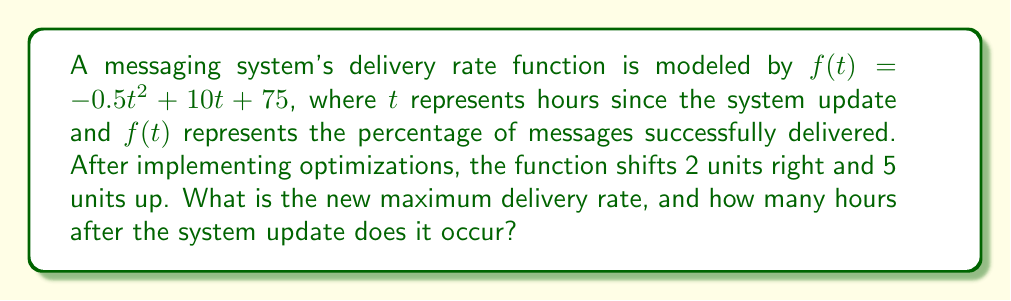Teach me how to tackle this problem. Let's approach this step-by-step:

1) The original function is $f(t) = -0.5t^2 + 10t + 75$

2) After the shifts, the new function $g(t)$ is:
   $g(t) = -0.5(t-2)^2 + 10(t-2) + 75 + 5$

3) Expand $g(t)$:
   $g(t) = -0.5(t^2 - 4t + 4) + 10t - 20 + 80$
   $g(t) = -0.5t^2 + 2t - 2 + 10t - 20 + 80$
   $g(t) = -0.5t^2 + 12t + 58$

4) To find the maximum, we need to find the vertex of this parabola. For a quadratic function $at^2 + bt + c$, the t-coordinate of the vertex is given by $-b/(2a)$

5) Here, $a = -0.5$ and $b = 12$
   $t = -12 / (2(-0.5)) = 12$

6) The maximum occurs 12 hours after the system update

7) To find the maximum delivery rate, we substitute $t = 12$ into $g(t)$:
   $g(12) = -0.5(12)^2 + 12(12) + 58$
   $g(12) = -72 + 144 + 58 = 130$

Therefore, the new maximum delivery rate is 130%
Answer: The new maximum delivery rate is 130%, occurring 12 hours after the system update. 